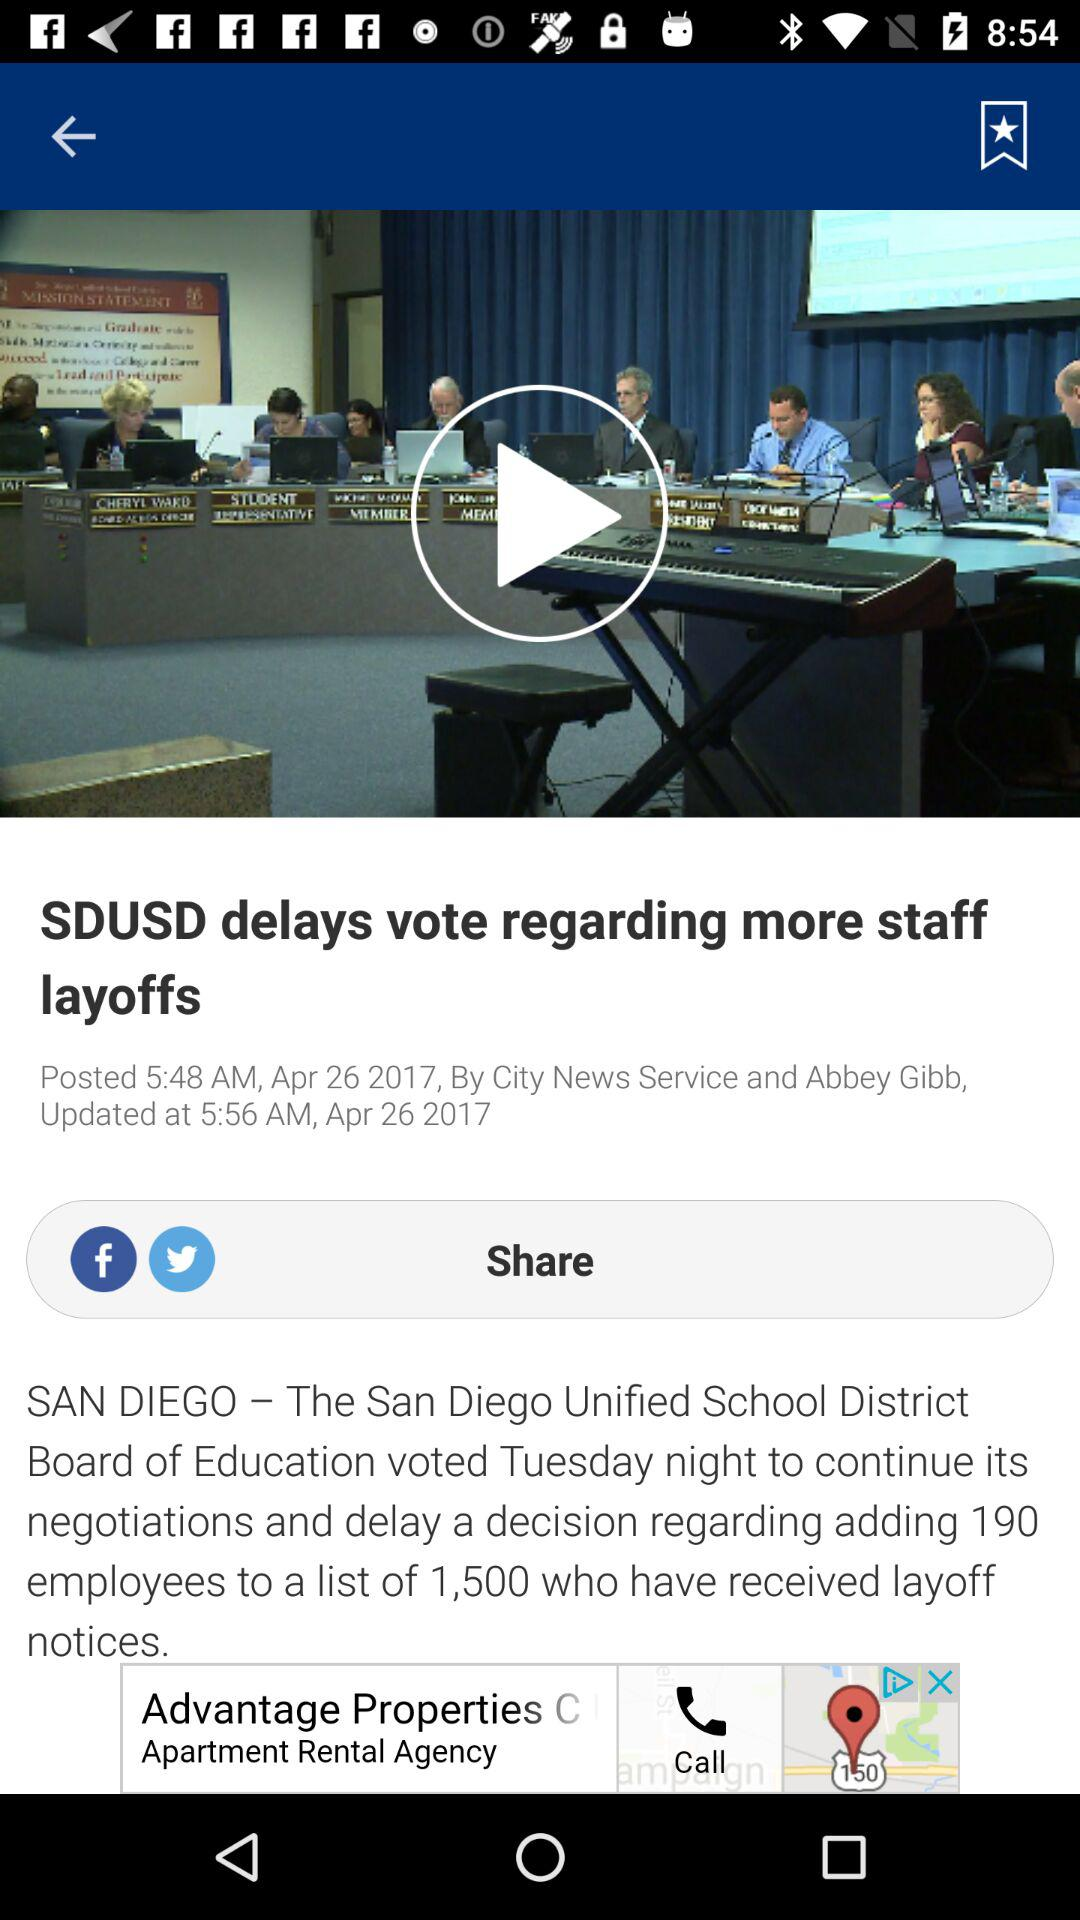What is the posted date? The posted date is April 26, 2017. 